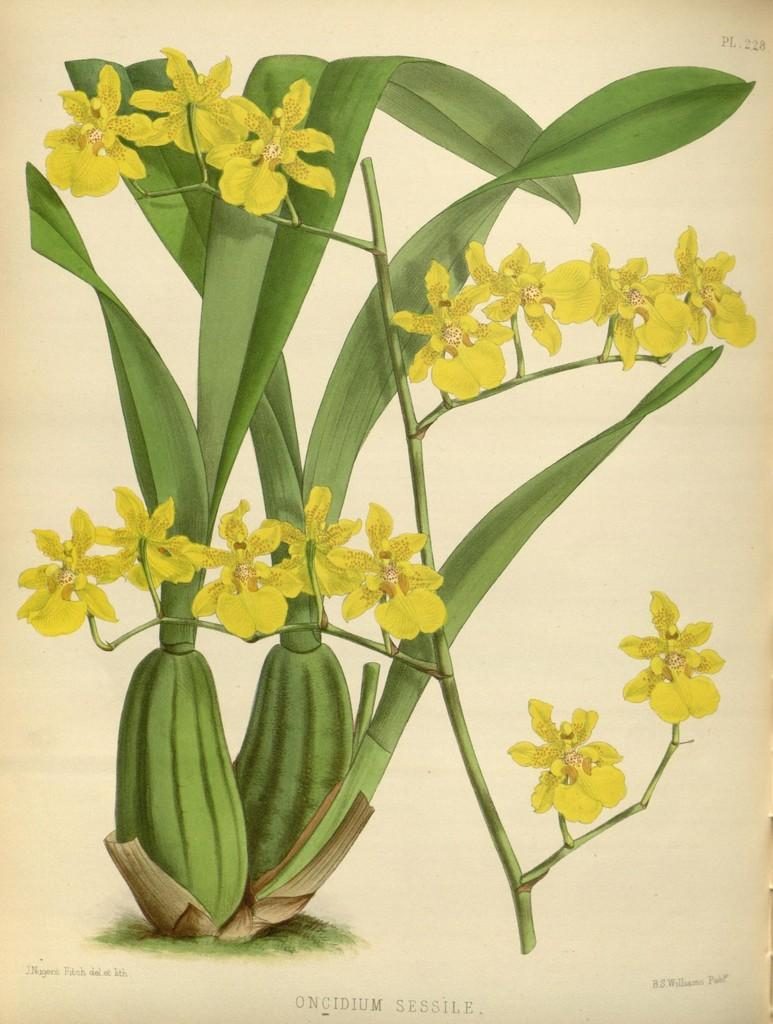What is featured on the poster in the image? The poster contains plants and flowers. What else can be seen on the poster besides the plants and flowers? There is text on the poster. How does the fork help with the digestion of the plants in the image? There is no fork present in the image, and the poster does not depict any digestion process. 